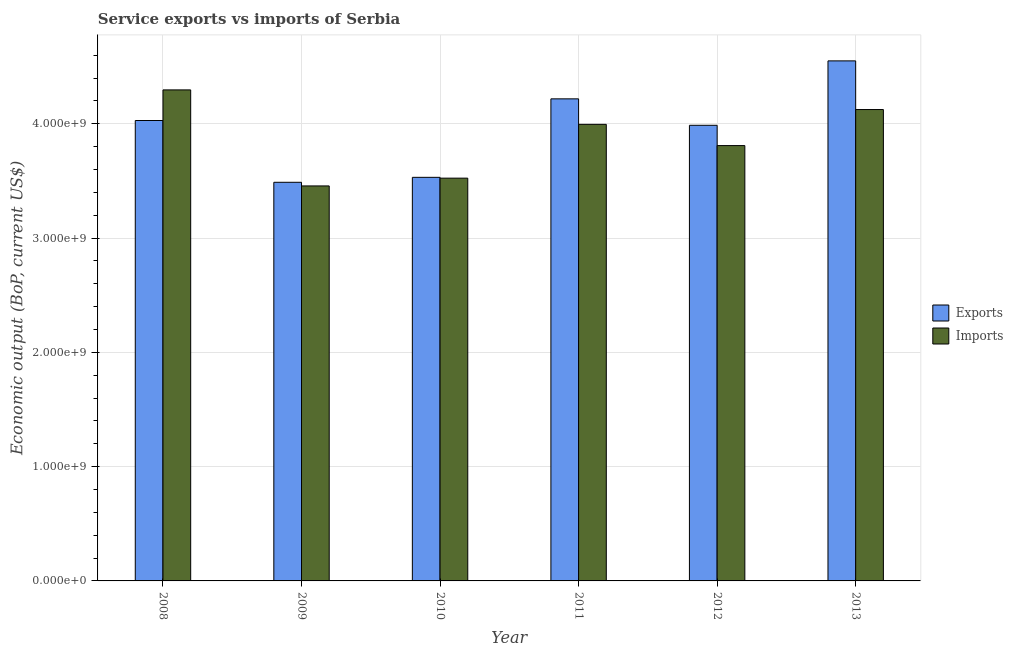How many groups of bars are there?
Provide a short and direct response. 6. Are the number of bars on each tick of the X-axis equal?
Give a very brief answer. Yes. How many bars are there on the 5th tick from the left?
Your response must be concise. 2. How many bars are there on the 6th tick from the right?
Provide a short and direct response. 2. What is the label of the 2nd group of bars from the left?
Provide a succinct answer. 2009. In how many cases, is the number of bars for a given year not equal to the number of legend labels?
Offer a very short reply. 0. What is the amount of service exports in 2010?
Provide a succinct answer. 3.53e+09. Across all years, what is the maximum amount of service imports?
Make the answer very short. 4.30e+09. Across all years, what is the minimum amount of service imports?
Your answer should be very brief. 3.46e+09. In which year was the amount of service exports maximum?
Offer a terse response. 2013. What is the total amount of service exports in the graph?
Your response must be concise. 2.38e+1. What is the difference between the amount of service imports in 2009 and that in 2010?
Provide a short and direct response. -6.81e+07. What is the difference between the amount of service exports in 2008 and the amount of service imports in 2009?
Provide a succinct answer. 5.40e+08. What is the average amount of service imports per year?
Provide a succinct answer. 3.87e+09. What is the ratio of the amount of service exports in 2009 to that in 2010?
Offer a terse response. 0.99. Is the difference between the amount of service exports in 2010 and 2012 greater than the difference between the amount of service imports in 2010 and 2012?
Provide a succinct answer. No. What is the difference between the highest and the second highest amount of service exports?
Provide a succinct answer. 3.32e+08. What is the difference between the highest and the lowest amount of service imports?
Your answer should be very brief. 8.40e+08. What does the 2nd bar from the left in 2011 represents?
Your answer should be compact. Imports. What does the 2nd bar from the right in 2011 represents?
Offer a very short reply. Exports. Are all the bars in the graph horizontal?
Offer a terse response. No. How many years are there in the graph?
Make the answer very short. 6. Does the graph contain any zero values?
Keep it short and to the point. No. Does the graph contain grids?
Keep it short and to the point. Yes. How many legend labels are there?
Give a very brief answer. 2. What is the title of the graph?
Provide a short and direct response. Service exports vs imports of Serbia. Does "Under five" appear as one of the legend labels in the graph?
Your response must be concise. No. What is the label or title of the X-axis?
Keep it short and to the point. Year. What is the label or title of the Y-axis?
Keep it short and to the point. Economic output (BoP, current US$). What is the Economic output (BoP, current US$) in Exports in 2008?
Ensure brevity in your answer.  4.03e+09. What is the Economic output (BoP, current US$) of Imports in 2008?
Give a very brief answer. 4.30e+09. What is the Economic output (BoP, current US$) of Exports in 2009?
Give a very brief answer. 3.49e+09. What is the Economic output (BoP, current US$) of Imports in 2009?
Keep it short and to the point. 3.46e+09. What is the Economic output (BoP, current US$) of Exports in 2010?
Provide a succinct answer. 3.53e+09. What is the Economic output (BoP, current US$) in Imports in 2010?
Provide a short and direct response. 3.52e+09. What is the Economic output (BoP, current US$) in Exports in 2011?
Provide a succinct answer. 4.22e+09. What is the Economic output (BoP, current US$) in Imports in 2011?
Offer a terse response. 3.99e+09. What is the Economic output (BoP, current US$) in Exports in 2012?
Make the answer very short. 3.99e+09. What is the Economic output (BoP, current US$) in Imports in 2012?
Offer a very short reply. 3.81e+09. What is the Economic output (BoP, current US$) in Exports in 2013?
Your answer should be very brief. 4.55e+09. What is the Economic output (BoP, current US$) in Imports in 2013?
Ensure brevity in your answer.  4.12e+09. Across all years, what is the maximum Economic output (BoP, current US$) in Exports?
Ensure brevity in your answer.  4.55e+09. Across all years, what is the maximum Economic output (BoP, current US$) in Imports?
Offer a terse response. 4.30e+09. Across all years, what is the minimum Economic output (BoP, current US$) in Exports?
Your response must be concise. 3.49e+09. Across all years, what is the minimum Economic output (BoP, current US$) of Imports?
Provide a short and direct response. 3.46e+09. What is the total Economic output (BoP, current US$) in Exports in the graph?
Your answer should be compact. 2.38e+1. What is the total Economic output (BoP, current US$) of Imports in the graph?
Make the answer very short. 2.32e+1. What is the difference between the Economic output (BoP, current US$) of Exports in 2008 and that in 2009?
Ensure brevity in your answer.  5.40e+08. What is the difference between the Economic output (BoP, current US$) in Imports in 2008 and that in 2009?
Your answer should be very brief. 8.40e+08. What is the difference between the Economic output (BoP, current US$) in Exports in 2008 and that in 2010?
Offer a terse response. 4.97e+08. What is the difference between the Economic output (BoP, current US$) in Imports in 2008 and that in 2010?
Keep it short and to the point. 7.72e+08. What is the difference between the Economic output (BoP, current US$) in Exports in 2008 and that in 2011?
Provide a succinct answer. -1.90e+08. What is the difference between the Economic output (BoP, current US$) of Imports in 2008 and that in 2011?
Offer a very short reply. 3.01e+08. What is the difference between the Economic output (BoP, current US$) of Exports in 2008 and that in 2012?
Provide a succinct answer. 4.19e+07. What is the difference between the Economic output (BoP, current US$) of Imports in 2008 and that in 2012?
Your answer should be very brief. 4.87e+08. What is the difference between the Economic output (BoP, current US$) in Exports in 2008 and that in 2013?
Your answer should be very brief. -5.22e+08. What is the difference between the Economic output (BoP, current US$) of Imports in 2008 and that in 2013?
Your answer should be very brief. 1.72e+08. What is the difference between the Economic output (BoP, current US$) in Exports in 2009 and that in 2010?
Your answer should be compact. -4.33e+07. What is the difference between the Economic output (BoP, current US$) of Imports in 2009 and that in 2010?
Your answer should be very brief. -6.81e+07. What is the difference between the Economic output (BoP, current US$) in Exports in 2009 and that in 2011?
Ensure brevity in your answer.  -7.30e+08. What is the difference between the Economic output (BoP, current US$) in Imports in 2009 and that in 2011?
Provide a short and direct response. -5.39e+08. What is the difference between the Economic output (BoP, current US$) of Exports in 2009 and that in 2012?
Provide a short and direct response. -4.99e+08. What is the difference between the Economic output (BoP, current US$) in Imports in 2009 and that in 2012?
Offer a very short reply. -3.53e+08. What is the difference between the Economic output (BoP, current US$) of Exports in 2009 and that in 2013?
Your answer should be very brief. -1.06e+09. What is the difference between the Economic output (BoP, current US$) in Imports in 2009 and that in 2013?
Your response must be concise. -6.68e+08. What is the difference between the Economic output (BoP, current US$) in Exports in 2010 and that in 2011?
Your answer should be compact. -6.87e+08. What is the difference between the Economic output (BoP, current US$) of Imports in 2010 and that in 2011?
Give a very brief answer. -4.71e+08. What is the difference between the Economic output (BoP, current US$) of Exports in 2010 and that in 2012?
Offer a terse response. -4.55e+08. What is the difference between the Economic output (BoP, current US$) in Imports in 2010 and that in 2012?
Your response must be concise. -2.85e+08. What is the difference between the Economic output (BoP, current US$) of Exports in 2010 and that in 2013?
Offer a very short reply. -1.02e+09. What is the difference between the Economic output (BoP, current US$) in Imports in 2010 and that in 2013?
Offer a terse response. -6.00e+08. What is the difference between the Economic output (BoP, current US$) of Exports in 2011 and that in 2012?
Your answer should be compact. 2.31e+08. What is the difference between the Economic output (BoP, current US$) in Imports in 2011 and that in 2012?
Ensure brevity in your answer.  1.86e+08. What is the difference between the Economic output (BoP, current US$) in Exports in 2011 and that in 2013?
Provide a short and direct response. -3.32e+08. What is the difference between the Economic output (BoP, current US$) in Imports in 2011 and that in 2013?
Offer a very short reply. -1.30e+08. What is the difference between the Economic output (BoP, current US$) of Exports in 2012 and that in 2013?
Offer a terse response. -5.64e+08. What is the difference between the Economic output (BoP, current US$) in Imports in 2012 and that in 2013?
Your answer should be compact. -3.15e+08. What is the difference between the Economic output (BoP, current US$) in Exports in 2008 and the Economic output (BoP, current US$) in Imports in 2009?
Offer a terse response. 5.72e+08. What is the difference between the Economic output (BoP, current US$) of Exports in 2008 and the Economic output (BoP, current US$) of Imports in 2010?
Provide a short and direct response. 5.04e+08. What is the difference between the Economic output (BoP, current US$) in Exports in 2008 and the Economic output (BoP, current US$) in Imports in 2011?
Provide a short and direct response. 3.36e+07. What is the difference between the Economic output (BoP, current US$) in Exports in 2008 and the Economic output (BoP, current US$) in Imports in 2012?
Give a very brief answer. 2.19e+08. What is the difference between the Economic output (BoP, current US$) in Exports in 2008 and the Economic output (BoP, current US$) in Imports in 2013?
Your answer should be very brief. -9.60e+07. What is the difference between the Economic output (BoP, current US$) in Exports in 2009 and the Economic output (BoP, current US$) in Imports in 2010?
Your answer should be very brief. -3.62e+07. What is the difference between the Economic output (BoP, current US$) in Exports in 2009 and the Economic output (BoP, current US$) in Imports in 2011?
Provide a short and direct response. -5.07e+08. What is the difference between the Economic output (BoP, current US$) of Exports in 2009 and the Economic output (BoP, current US$) of Imports in 2012?
Offer a terse response. -3.21e+08. What is the difference between the Economic output (BoP, current US$) of Exports in 2009 and the Economic output (BoP, current US$) of Imports in 2013?
Ensure brevity in your answer.  -6.36e+08. What is the difference between the Economic output (BoP, current US$) in Exports in 2010 and the Economic output (BoP, current US$) in Imports in 2011?
Provide a short and direct response. -4.64e+08. What is the difference between the Economic output (BoP, current US$) in Exports in 2010 and the Economic output (BoP, current US$) in Imports in 2012?
Your response must be concise. -2.78e+08. What is the difference between the Economic output (BoP, current US$) of Exports in 2010 and the Economic output (BoP, current US$) of Imports in 2013?
Give a very brief answer. -5.93e+08. What is the difference between the Economic output (BoP, current US$) of Exports in 2011 and the Economic output (BoP, current US$) of Imports in 2012?
Your answer should be compact. 4.09e+08. What is the difference between the Economic output (BoP, current US$) of Exports in 2011 and the Economic output (BoP, current US$) of Imports in 2013?
Provide a short and direct response. 9.35e+07. What is the difference between the Economic output (BoP, current US$) in Exports in 2012 and the Economic output (BoP, current US$) in Imports in 2013?
Your answer should be very brief. -1.38e+08. What is the average Economic output (BoP, current US$) of Exports per year?
Give a very brief answer. 3.97e+09. What is the average Economic output (BoP, current US$) of Imports per year?
Offer a very short reply. 3.87e+09. In the year 2008, what is the difference between the Economic output (BoP, current US$) in Exports and Economic output (BoP, current US$) in Imports?
Make the answer very short. -2.68e+08. In the year 2009, what is the difference between the Economic output (BoP, current US$) in Exports and Economic output (BoP, current US$) in Imports?
Offer a terse response. 3.18e+07. In the year 2010, what is the difference between the Economic output (BoP, current US$) of Exports and Economic output (BoP, current US$) of Imports?
Your answer should be compact. 7.06e+06. In the year 2011, what is the difference between the Economic output (BoP, current US$) in Exports and Economic output (BoP, current US$) in Imports?
Your response must be concise. 2.23e+08. In the year 2012, what is the difference between the Economic output (BoP, current US$) of Exports and Economic output (BoP, current US$) of Imports?
Your answer should be very brief. 1.78e+08. In the year 2013, what is the difference between the Economic output (BoP, current US$) in Exports and Economic output (BoP, current US$) in Imports?
Your answer should be compact. 4.26e+08. What is the ratio of the Economic output (BoP, current US$) of Exports in 2008 to that in 2009?
Your answer should be compact. 1.16. What is the ratio of the Economic output (BoP, current US$) of Imports in 2008 to that in 2009?
Offer a very short reply. 1.24. What is the ratio of the Economic output (BoP, current US$) of Exports in 2008 to that in 2010?
Ensure brevity in your answer.  1.14. What is the ratio of the Economic output (BoP, current US$) of Imports in 2008 to that in 2010?
Offer a terse response. 1.22. What is the ratio of the Economic output (BoP, current US$) of Exports in 2008 to that in 2011?
Offer a very short reply. 0.96. What is the ratio of the Economic output (BoP, current US$) of Imports in 2008 to that in 2011?
Give a very brief answer. 1.08. What is the ratio of the Economic output (BoP, current US$) of Exports in 2008 to that in 2012?
Give a very brief answer. 1.01. What is the ratio of the Economic output (BoP, current US$) of Imports in 2008 to that in 2012?
Give a very brief answer. 1.13. What is the ratio of the Economic output (BoP, current US$) in Exports in 2008 to that in 2013?
Your answer should be very brief. 0.89. What is the ratio of the Economic output (BoP, current US$) of Imports in 2008 to that in 2013?
Your answer should be very brief. 1.04. What is the ratio of the Economic output (BoP, current US$) in Exports in 2009 to that in 2010?
Offer a very short reply. 0.99. What is the ratio of the Economic output (BoP, current US$) in Imports in 2009 to that in 2010?
Offer a terse response. 0.98. What is the ratio of the Economic output (BoP, current US$) of Exports in 2009 to that in 2011?
Offer a very short reply. 0.83. What is the ratio of the Economic output (BoP, current US$) of Imports in 2009 to that in 2011?
Provide a succinct answer. 0.87. What is the ratio of the Economic output (BoP, current US$) of Exports in 2009 to that in 2012?
Offer a very short reply. 0.87. What is the ratio of the Economic output (BoP, current US$) of Imports in 2009 to that in 2012?
Offer a terse response. 0.91. What is the ratio of the Economic output (BoP, current US$) in Exports in 2009 to that in 2013?
Make the answer very short. 0.77. What is the ratio of the Economic output (BoP, current US$) of Imports in 2009 to that in 2013?
Your answer should be compact. 0.84. What is the ratio of the Economic output (BoP, current US$) of Exports in 2010 to that in 2011?
Your response must be concise. 0.84. What is the ratio of the Economic output (BoP, current US$) in Imports in 2010 to that in 2011?
Provide a short and direct response. 0.88. What is the ratio of the Economic output (BoP, current US$) of Exports in 2010 to that in 2012?
Offer a terse response. 0.89. What is the ratio of the Economic output (BoP, current US$) in Imports in 2010 to that in 2012?
Your answer should be compact. 0.93. What is the ratio of the Economic output (BoP, current US$) of Exports in 2010 to that in 2013?
Offer a very short reply. 0.78. What is the ratio of the Economic output (BoP, current US$) of Imports in 2010 to that in 2013?
Provide a succinct answer. 0.85. What is the ratio of the Economic output (BoP, current US$) in Exports in 2011 to that in 2012?
Provide a short and direct response. 1.06. What is the ratio of the Economic output (BoP, current US$) of Imports in 2011 to that in 2012?
Your response must be concise. 1.05. What is the ratio of the Economic output (BoP, current US$) of Exports in 2011 to that in 2013?
Provide a succinct answer. 0.93. What is the ratio of the Economic output (BoP, current US$) of Imports in 2011 to that in 2013?
Provide a short and direct response. 0.97. What is the ratio of the Economic output (BoP, current US$) in Exports in 2012 to that in 2013?
Offer a terse response. 0.88. What is the ratio of the Economic output (BoP, current US$) of Imports in 2012 to that in 2013?
Give a very brief answer. 0.92. What is the difference between the highest and the second highest Economic output (BoP, current US$) in Exports?
Keep it short and to the point. 3.32e+08. What is the difference between the highest and the second highest Economic output (BoP, current US$) of Imports?
Keep it short and to the point. 1.72e+08. What is the difference between the highest and the lowest Economic output (BoP, current US$) in Exports?
Give a very brief answer. 1.06e+09. What is the difference between the highest and the lowest Economic output (BoP, current US$) of Imports?
Your answer should be very brief. 8.40e+08. 